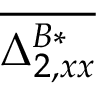<formula> <loc_0><loc_0><loc_500><loc_500>\overline { { \Delta _ { 2 , x x } ^ { B * } } }</formula> 